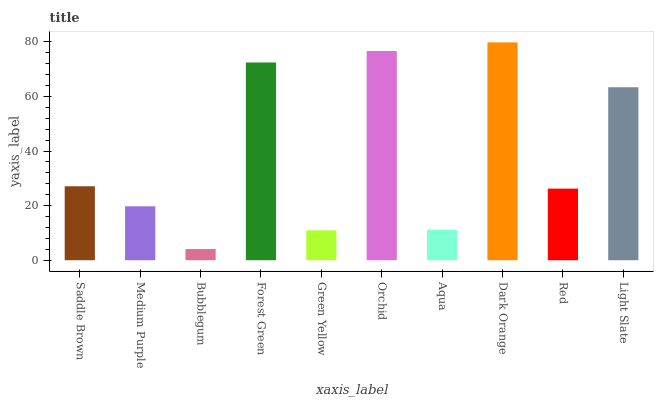Is Medium Purple the minimum?
Answer yes or no. No. Is Medium Purple the maximum?
Answer yes or no. No. Is Saddle Brown greater than Medium Purple?
Answer yes or no. Yes. Is Medium Purple less than Saddle Brown?
Answer yes or no. Yes. Is Medium Purple greater than Saddle Brown?
Answer yes or no. No. Is Saddle Brown less than Medium Purple?
Answer yes or no. No. Is Saddle Brown the high median?
Answer yes or no. Yes. Is Red the low median?
Answer yes or no. Yes. Is Light Slate the high median?
Answer yes or no. No. Is Bubblegum the low median?
Answer yes or no. No. 